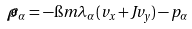Convert formula to latex. <formula><loc_0><loc_0><loc_500><loc_500>\widetilde { \rho } _ { \alpha } = - \i m \lambda _ { \alpha } ( v _ { x } + J v _ { y } ) - p _ { \alpha }</formula> 